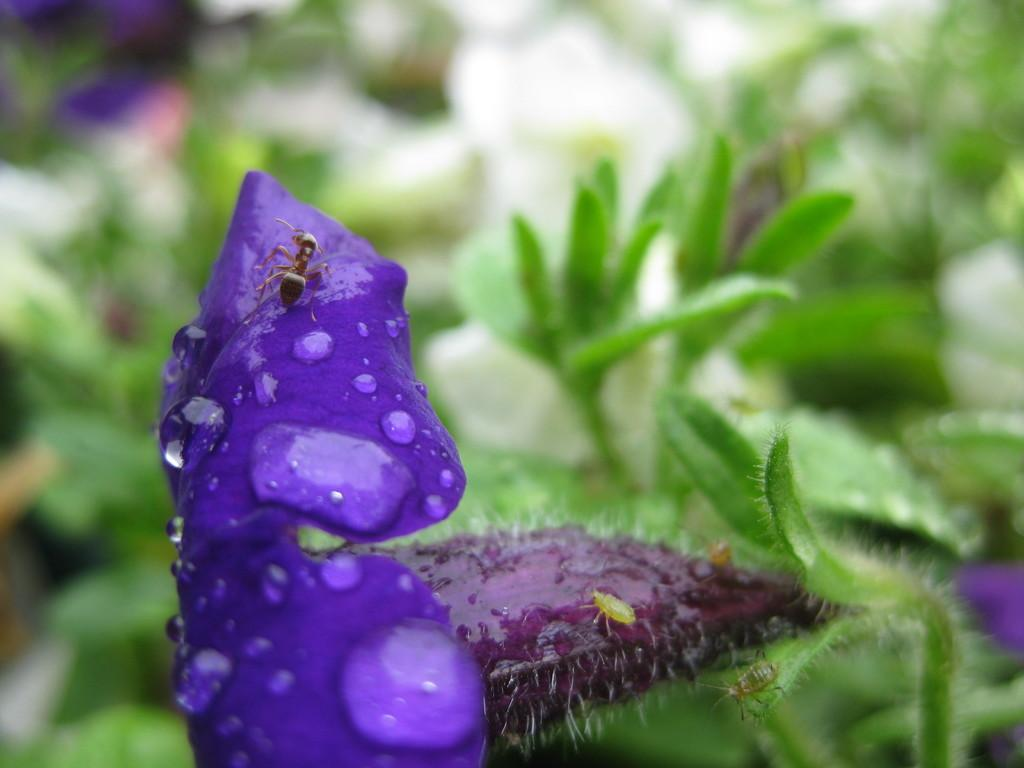What type of plant material can be seen in the image? There are leaves visible in the image. What type of flower is present in the image? There is a flower visible in the image, and its petals are violet in color. What is present on the flower in the image? There are water drops and insects on the flower in the image. How would you describe the background of the image? The background of the image is blurred. What verse is being recited by the band in the image? There is no band or verse present in the image; it features a flower with leaves, water drops, and insects against a blurred background. 